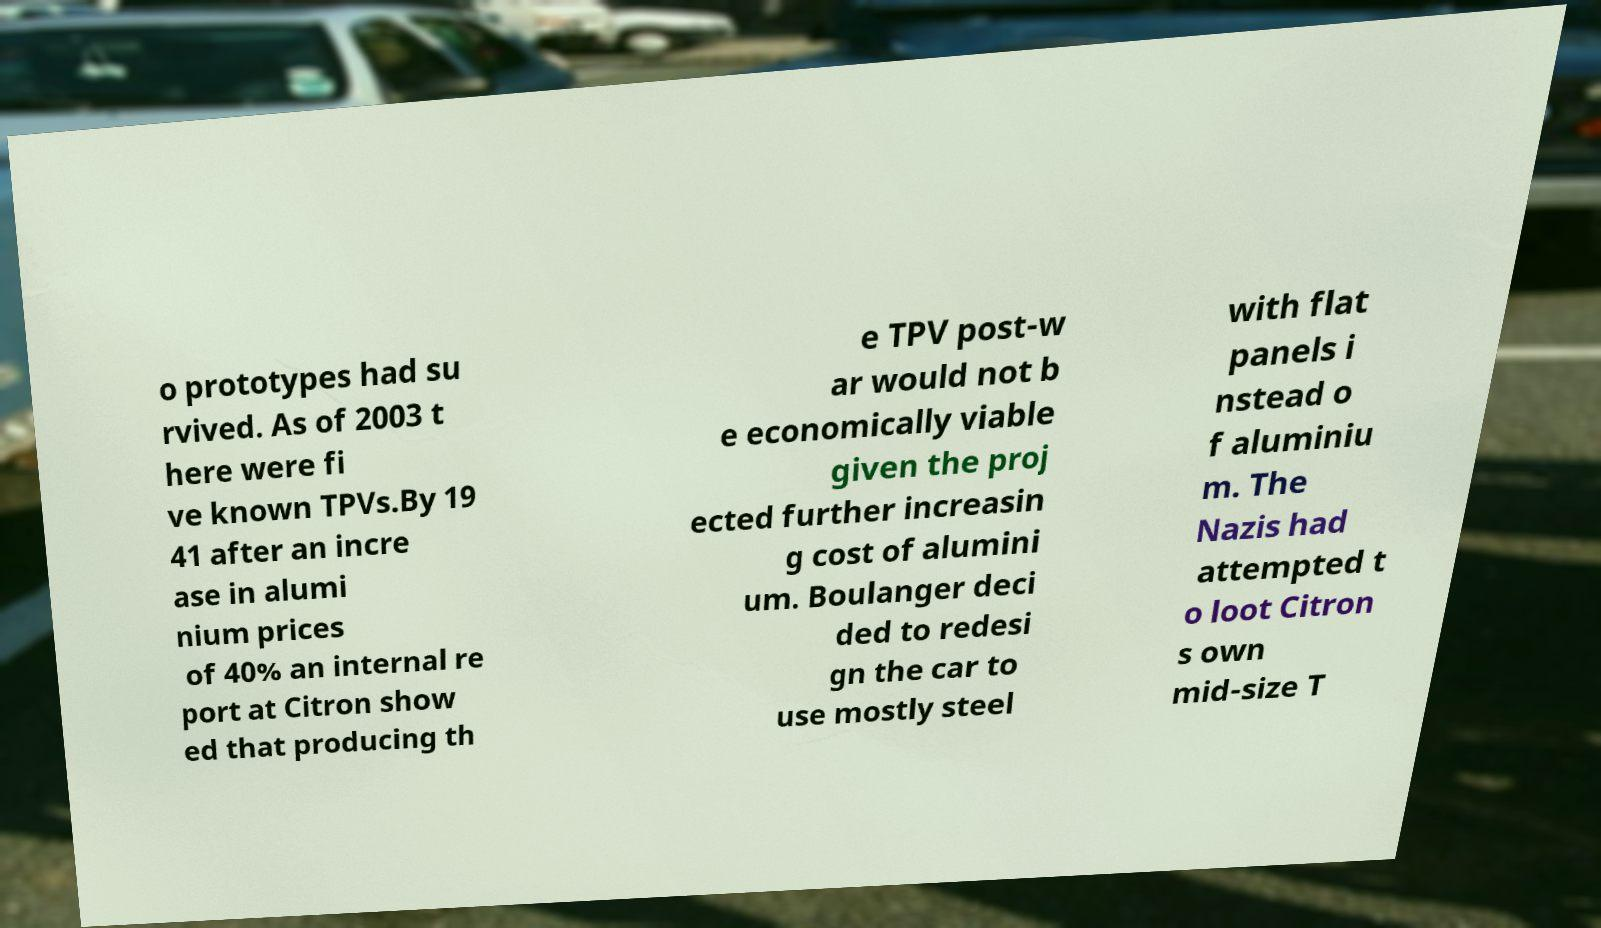I need the written content from this picture converted into text. Can you do that? o prototypes had su rvived. As of 2003 t here were fi ve known TPVs.By 19 41 after an incre ase in alumi nium prices of 40% an internal re port at Citron show ed that producing th e TPV post-w ar would not b e economically viable given the proj ected further increasin g cost of alumini um. Boulanger deci ded to redesi gn the car to use mostly steel with flat panels i nstead o f aluminiu m. The Nazis had attempted t o loot Citron s own mid-size T 